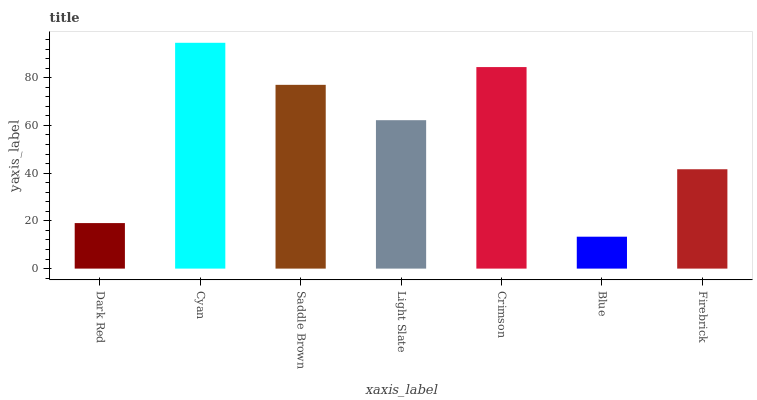Is Saddle Brown the minimum?
Answer yes or no. No. Is Saddle Brown the maximum?
Answer yes or no. No. Is Cyan greater than Saddle Brown?
Answer yes or no. Yes. Is Saddle Brown less than Cyan?
Answer yes or no. Yes. Is Saddle Brown greater than Cyan?
Answer yes or no. No. Is Cyan less than Saddle Brown?
Answer yes or no. No. Is Light Slate the high median?
Answer yes or no. Yes. Is Light Slate the low median?
Answer yes or no. Yes. Is Firebrick the high median?
Answer yes or no. No. Is Crimson the low median?
Answer yes or no. No. 